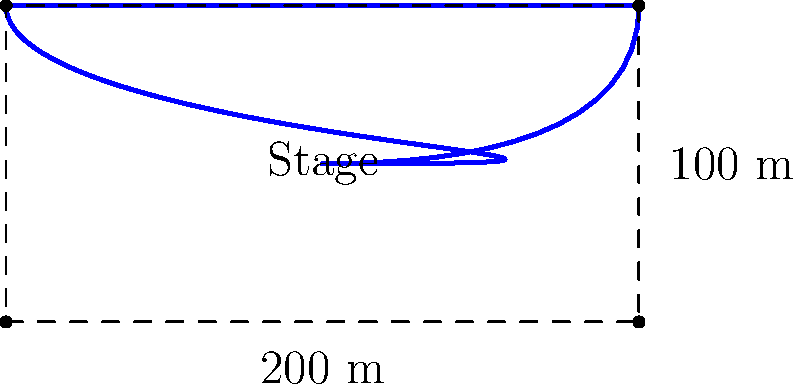A world music festival is planning to construct a guitar-shaped stage within a rectangular area. The rectangular area measures 200 meters in length and 100 meters in width. If the perimeter of the guitar-shaped stage is 80% of the perimeter of the rectangular area, what is the length of the perimeter of the guitar-shaped stage in meters? To solve this problem, let's follow these steps:

1) First, calculate the perimeter of the rectangular area:
   $$P_{rectangle} = 2(length + width) = 2(200 + 100) = 2(300) = 600 \text{ meters}$$

2) The guitar-shaped stage's perimeter is 80% of the rectangular area's perimeter:
   $$P_{guitar} = 80\% \times P_{rectangle}$$

3) Convert the percentage to a decimal:
   $$80\% = 0.80$$

4) Calculate the perimeter of the guitar-shaped stage:
   $$P_{guitar} = 0.80 \times 600 = 480 \text{ meters}$$

Therefore, the perimeter of the guitar-shaped stage is 480 meters.
Answer: 480 meters 